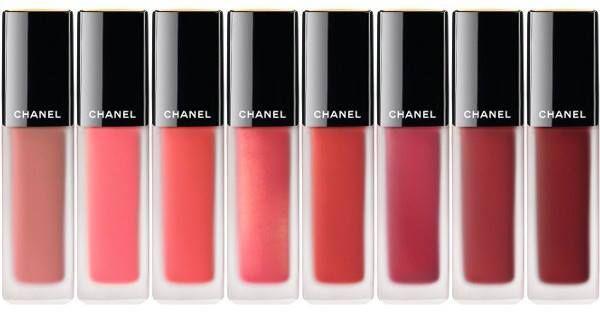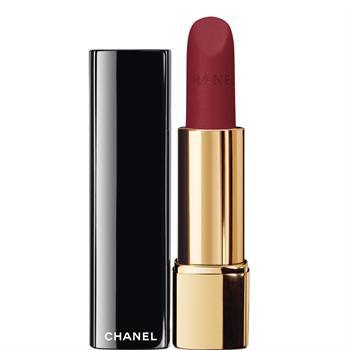The first image is the image on the left, the second image is the image on the right. Evaluate the accuracy of this statement regarding the images: "An image shows exactly one lip makeup item, displayed with its cap removed.". Is it true? Answer yes or no. Yes. The first image is the image on the left, the second image is the image on the right. Assess this claim about the two images: "lipsticks are shown with the lids off". Correct or not? Answer yes or no. Yes. 